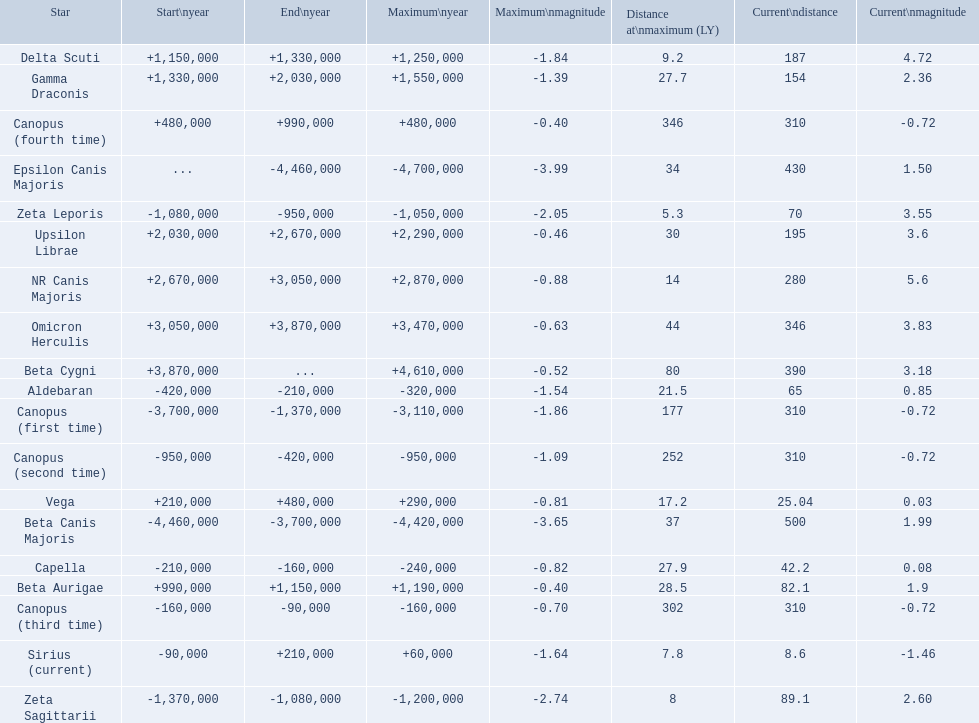What are all the stars? Epsilon Canis Majoris, Beta Canis Majoris, Canopus (first time), Zeta Sagittarii, Zeta Leporis, Canopus (second time), Aldebaran, Capella, Canopus (third time), Sirius (current), Vega, Canopus (fourth time), Beta Aurigae, Delta Scuti, Gamma Draconis, Upsilon Librae, NR Canis Majoris, Omicron Herculis, Beta Cygni. Of those, which star has a maximum distance of 80? Beta Cygni. 